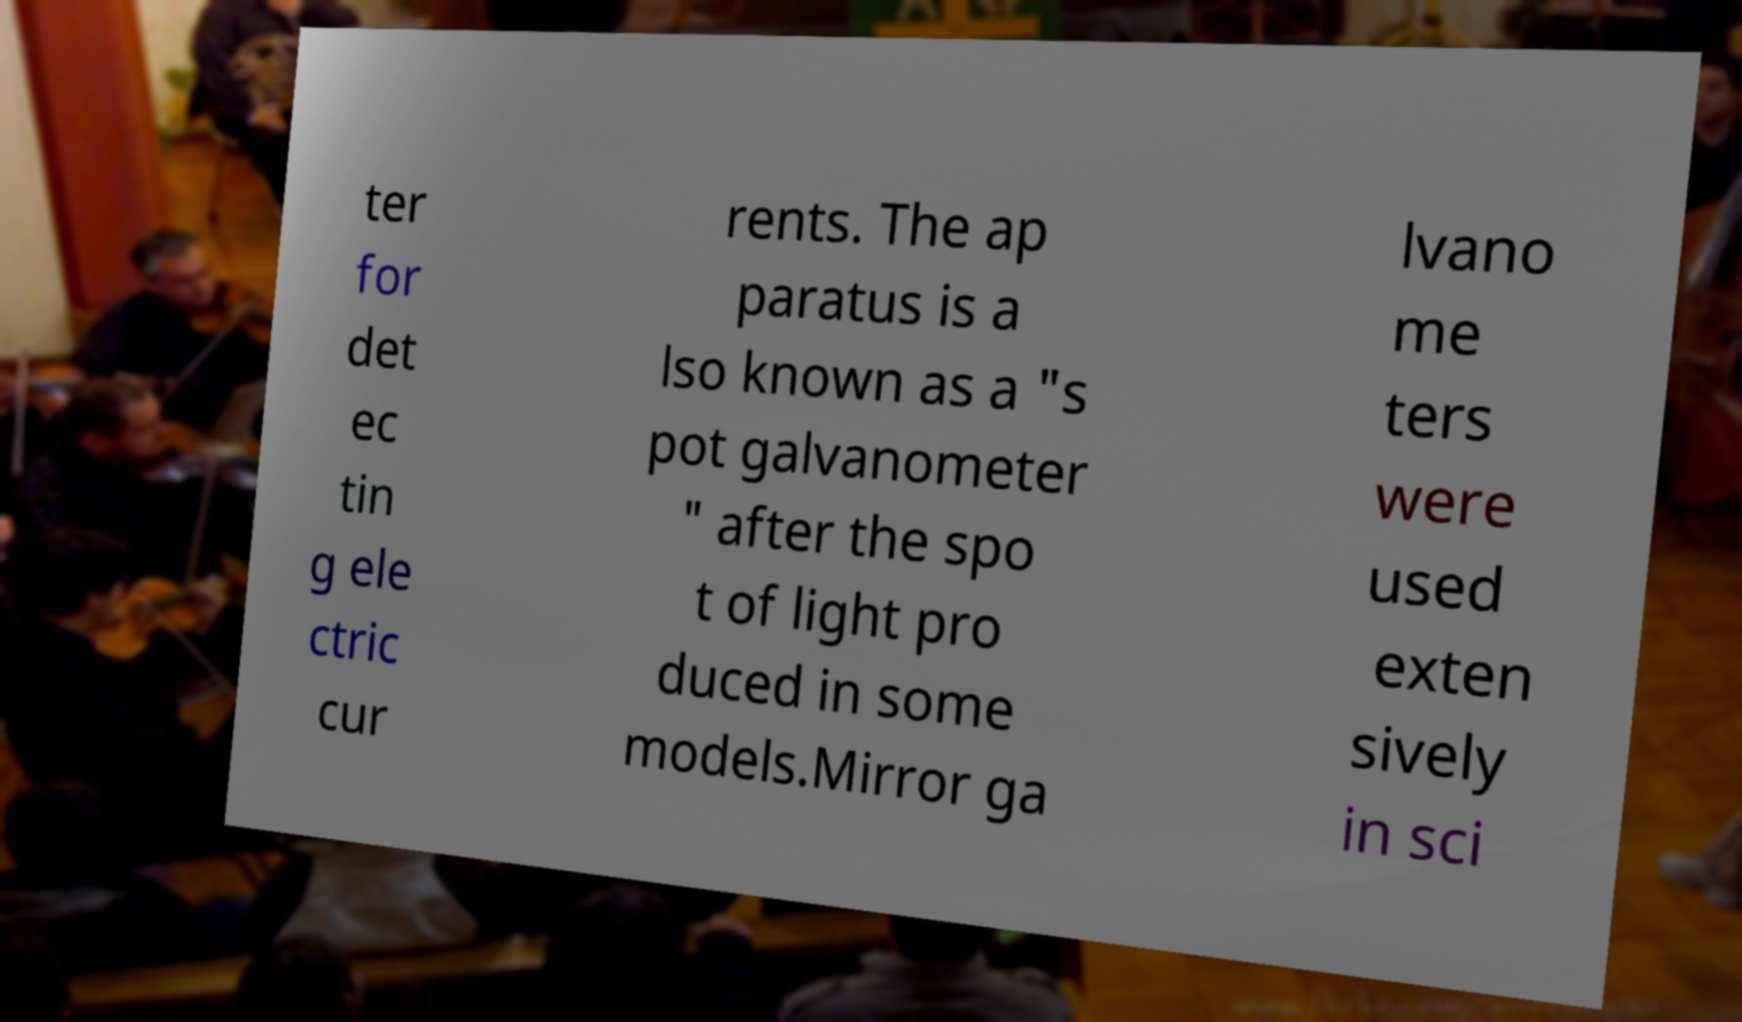Can you accurately transcribe the text from the provided image for me? ter for det ec tin g ele ctric cur rents. The ap paratus is a lso known as a "s pot galvanometer " after the spo t of light pro duced in some models.Mirror ga lvano me ters were used exten sively in sci 